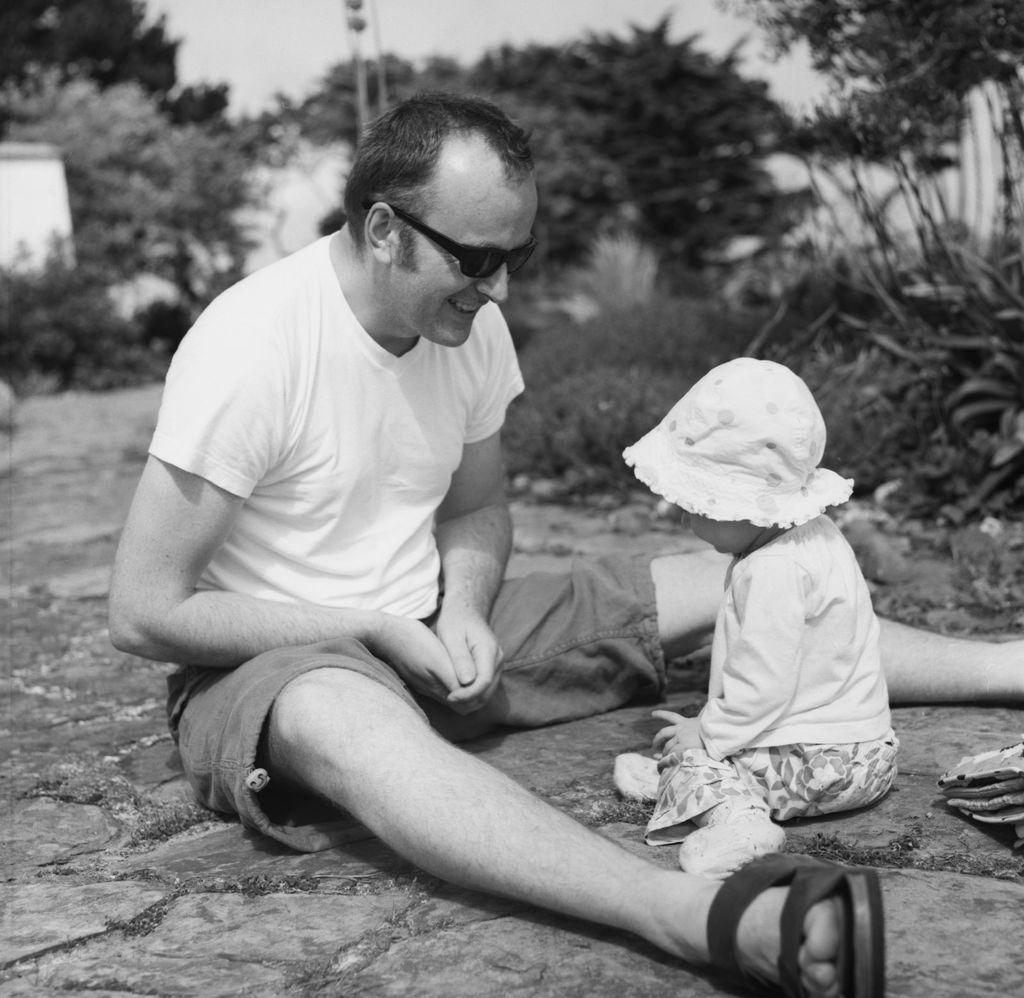What is the color scheme of the image? The image is black and white. What is the man in the image doing? The man is sitting on the floor and playing with a kid. Where is the kid positioned in relation to the man? The kid is in front of the man. What can be seen in the background of the image? There are trees in the background of the image. What subject is the man teaching the kid in the image? There is no indication in the image that the man is teaching the kid a specific subject. Can you describe the type of attack happening in the image? There is no attack depicted in the image; it shows a man playing with a kid. 